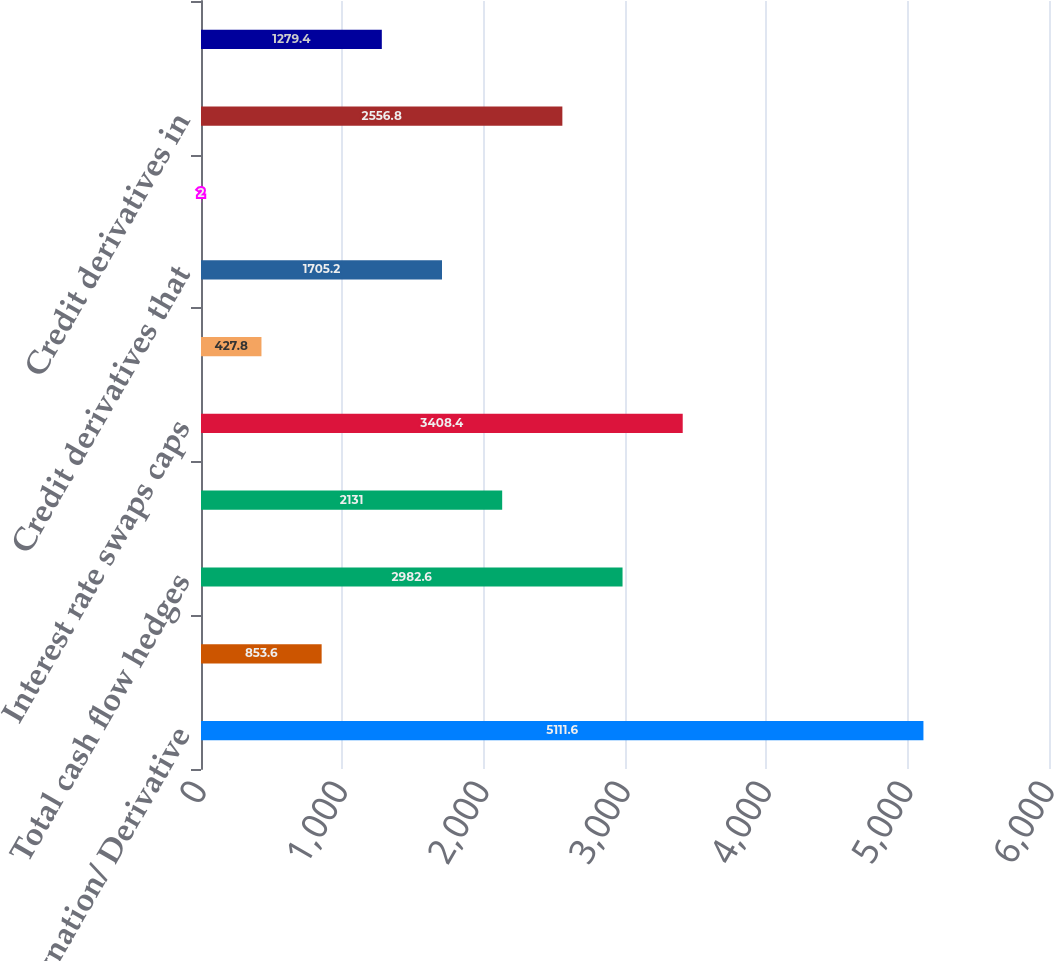<chart> <loc_0><loc_0><loc_500><loc_500><bar_chart><fcel>Hedge Designation/ Derivative<fcel>Foreign currency swaps<fcel>Total cash flow hedges<fcel>Total fair value hedges<fcel>Interest rate swaps caps<fcel>Foreign currency swaps and<fcel>Credit derivatives that<fcel>Credit derivatives that assume<fcel>Credit derivatives in<fcel>Equity index swaps and options<nl><fcel>5111.6<fcel>853.6<fcel>2982.6<fcel>2131<fcel>3408.4<fcel>427.8<fcel>1705.2<fcel>2<fcel>2556.8<fcel>1279.4<nl></chart> 